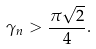Convert formula to latex. <formula><loc_0><loc_0><loc_500><loc_500>\gamma _ { n } > \frac { \pi \sqrt { 2 } } { 4 } .</formula> 